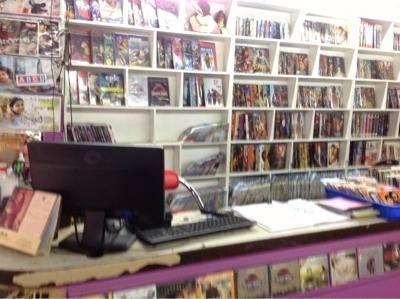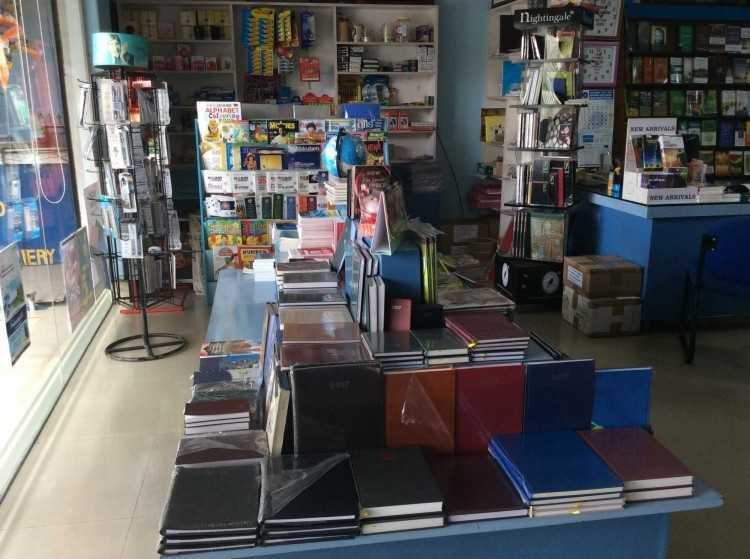The first image is the image on the left, the second image is the image on the right. Considering the images on both sides, is "At least one image shows a bookshop that uses royal blue in its color scheme." valid? Answer yes or no. Yes. 